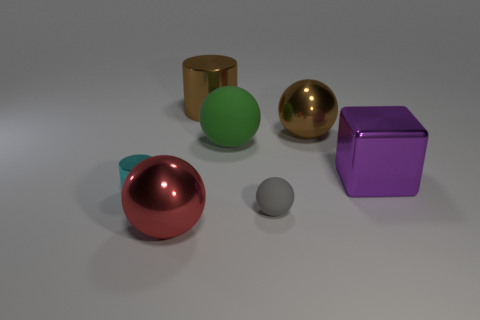What color is the cylinder that is the same size as the green thing?
Your answer should be compact. Brown. The metal thing that is both behind the purple object and in front of the brown cylinder is what color?
Your answer should be very brief. Brown. The object that is the same color as the big cylinder is what size?
Give a very brief answer. Large. What shape is the metallic object that is the same color as the large cylinder?
Offer a very short reply. Sphere. What is the size of the brown thing that is in front of the brown metal thing on the left side of the rubber object in front of the green sphere?
Give a very brief answer. Large. What material is the large red ball?
Provide a short and direct response. Metal. Is the large purple block made of the same material as the large brown thing that is to the right of the small rubber thing?
Ensure brevity in your answer.  Yes. Is there any other thing that is the same color as the big metallic cylinder?
Provide a succinct answer. Yes. There is a large metal ball left of the big ball that is on the right side of the green sphere; is there a big matte thing in front of it?
Offer a terse response. No. The large block is what color?
Your answer should be compact. Purple. 